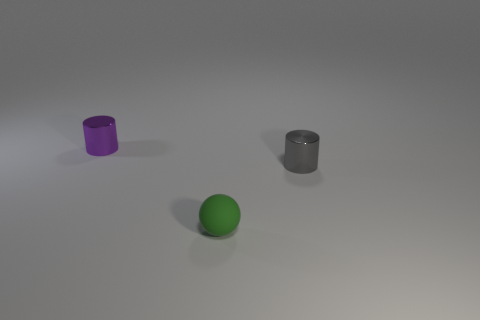Add 3 tiny matte objects. How many objects exist? 6 Subtract all cylinders. How many objects are left? 1 Add 2 tiny green rubber balls. How many tiny green rubber balls are left? 3 Add 1 metallic cylinders. How many metallic cylinders exist? 3 Subtract 1 purple cylinders. How many objects are left? 2 Subtract all big red metal blocks. Subtract all small cylinders. How many objects are left? 1 